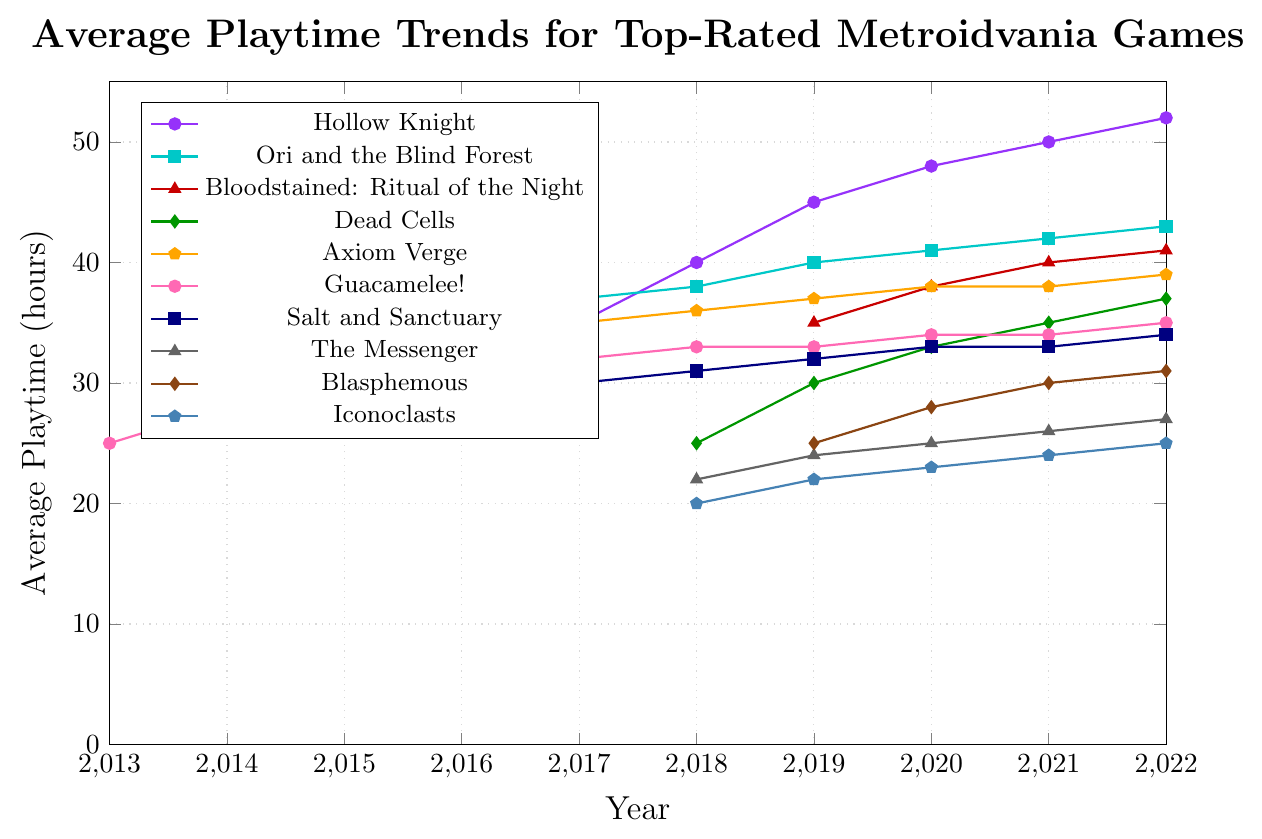Which game has the highest average playtime in 2017? Referencing the plot, the game with the highest point in 2017 is Ori and the Blind Forest, at 37 hours of average playtime.
Answer: Ori and the Blind Forest How did the average playtime for Dead Cells change between 2018 and 2022? From the plot, Dead Cells increased from 25 hours in 2018 to 37 hours in 2022. The changes were: 2018 (25), 2019 (30), 2020 (33), 2021 (35), and 2022 (37).
Answer: Increased (from 25 hours to 37 hours) Compare the average playtime of Hollow Knight and Salt and Sanctuary in 2022. Which one is higher and by how much? In 2022, Hollow Knight has an average playtime of 52 hours, while Salt and Sanctuary has 34 hours. The difference is 52 - 34 = 18.
Answer: Hollow Knight, by 18 hours What is the average playtime for games first released in 2018 (considering their 2022 values)? Considering the games released in 2018 are Dead Cells (37 hours), The Messenger (27 hours), and Iconoclasts (25 hours) in 2022. The average is (37 + 27 + 25) / 3 = 29.67.
Answer: 29.67 hours In which year did Guacamelee! reach an average playtime of 30 hours? Referring to the plot, Guacamelee! reached an average playtime of 30 hours in the year 2015.
Answer: 2015 Which game showed the most consistent increase in average playtime from 2016 to 2022? By observing the slopes of all the lines from 2016 to 2022, Axiom Verge shows a consistent increase without any decrease during the period.
Answer: Axiom Verge How much did the average playtime of Blasphemous increase from 2019 to 2022? From the plot, Blasphemous increased from 25 hours in 2019 to 31 hours in 2022. The increase is 31 - 25 = 6 hours.
Answer: 6 hours Identify the game with the least growth in average playtime from its release year to 2022. By comparing the lines in the chart, Guacamelee! (2013, increased by 10 hours from 2013 to 2022) shows the least growth in average playtime.
Answer: Guacamelee! What is the difference between the maximum average playtime in 2022 and the minimum average playtime in 2022 across all shown games? The maximum average playtime in 2022 is 52 hours (Hollow Knight) and the minimum is 25 hours (Iconoclasts). The difference is 52 - 25 = 27.
Answer: 27 hours 